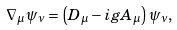<formula> <loc_0><loc_0><loc_500><loc_500>\nabla _ { \mu } \psi _ { \nu } = \left ( D _ { \mu } - i g A _ { \mu } \right ) \psi _ { \nu } ,</formula> 